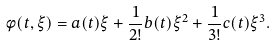<formula> <loc_0><loc_0><loc_500><loc_500>\phi ( t , \xi ) = a ( t ) \xi + \frac { 1 } { 2 ! } b ( t ) \xi ^ { 2 } + \frac { 1 } { 3 ! } c ( t ) \xi ^ { 3 } .</formula> 